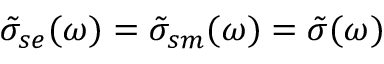<formula> <loc_0><loc_0><loc_500><loc_500>\tilde { \sigma } _ { s e } ( \omega ) = \tilde { \sigma } _ { s m } ( \omega ) = \tilde { \sigma } ( \omega )</formula> 